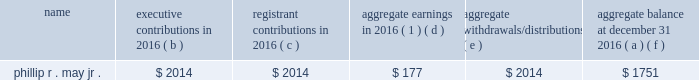2016 non-qualified deferred compensation as of december 31 , 2016 , mr .
May had a deferred account balance under a frozen defined contribution restoration plan .
The amount is deemed invested , as chosen by the participant , in certain t .
Rowe price investment funds that are also available to the participant under the savings plan .
Mr .
May has elected to receive the deferred account balance after he retires .
The defined contribution restoration plan , until it was frozen in 2005 , credited eligible employees 2019 deferral accounts with employer contributions to the extent contributions under the qualified savings plan in which the employee participated were subject to limitations imposed by the code .
Defined contribution restoration plan executive contributions in registrant contributions in aggregate earnings in 2016 ( 1 ) aggregate withdrawals/ distributions aggregate balance at december 31 , ( a ) ( b ) ( c ) ( d ) ( e ) ( f ) .
( 1 ) amounts in this column are not included in the summary compensation table .
2016 potential payments upon termination or change in control entergy corporation has plans and other arrangements that provide compensation to a named executive officer if his or her employment terminates under specified conditions , including following a change in control of entergy corporation .
In addition , in 2006 entergy corporation entered into a retention agreement with mr .
Denault that provides possibility of additional service credit under the system executive retirement plan upon certain terminations of employment .
There are no plans or agreements that would provide for payments to any of the named executive officers solely upon a change in control .
The tables below reflect the amount of compensation each of the named executive officers would have received if his or her employment with their entergy employer had been terminated under various scenarios as of december 31 , 2016 .
For purposes of these tables , a stock price of $ 73.47 was used , which was the closing market price on december 30 , 2016 , the last trading day of the year. .
What is the aggregate balance at december 31 2015 for phillip r . may jr.? 
Computations: (1751 - 177)
Answer: 1574.0. 